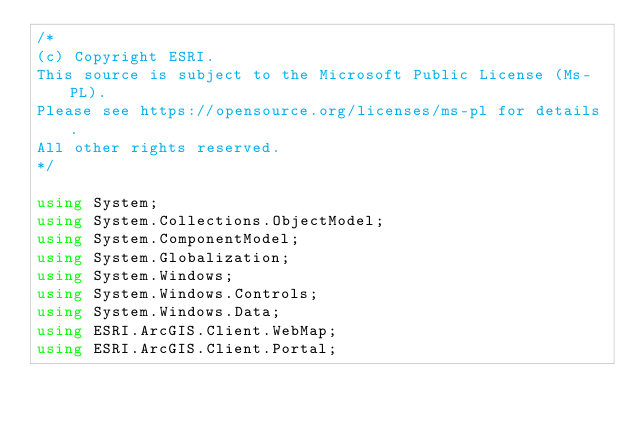<code> <loc_0><loc_0><loc_500><loc_500><_C#_>/*
(c) Copyright ESRI.
This source is subject to the Microsoft Public License (Ms-PL).
Please see https://opensource.org/licenses/ms-pl for details.
All other rights reserved.
*/

using System;
using System.Collections.ObjectModel;
using System.ComponentModel;
using System.Globalization;
using System.Windows;
using System.Windows.Controls;
using System.Windows.Data;
using ESRI.ArcGIS.Client.WebMap;
using ESRI.ArcGIS.Client.Portal;
</code> 